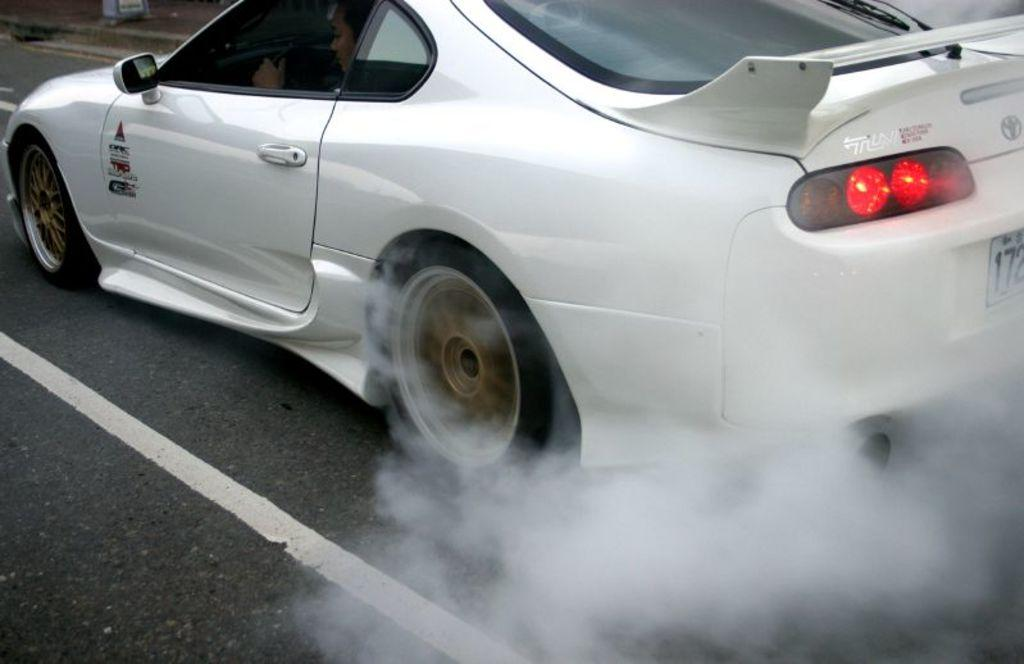What is the main subject of the image? The main subject of the image is a car on the road. Can you describe any additional details about the car? There is no additional information about the car provided in the facts. What else can be seen in the image besides the car? There is smoke visible in the image. What is located in the background of the image? There is an object on a footpath in the background of the image. What riddle is the woman trying to solve on the face of the object in the image? There is no woman or face present in the image, and therefore no riddle can be observed. 